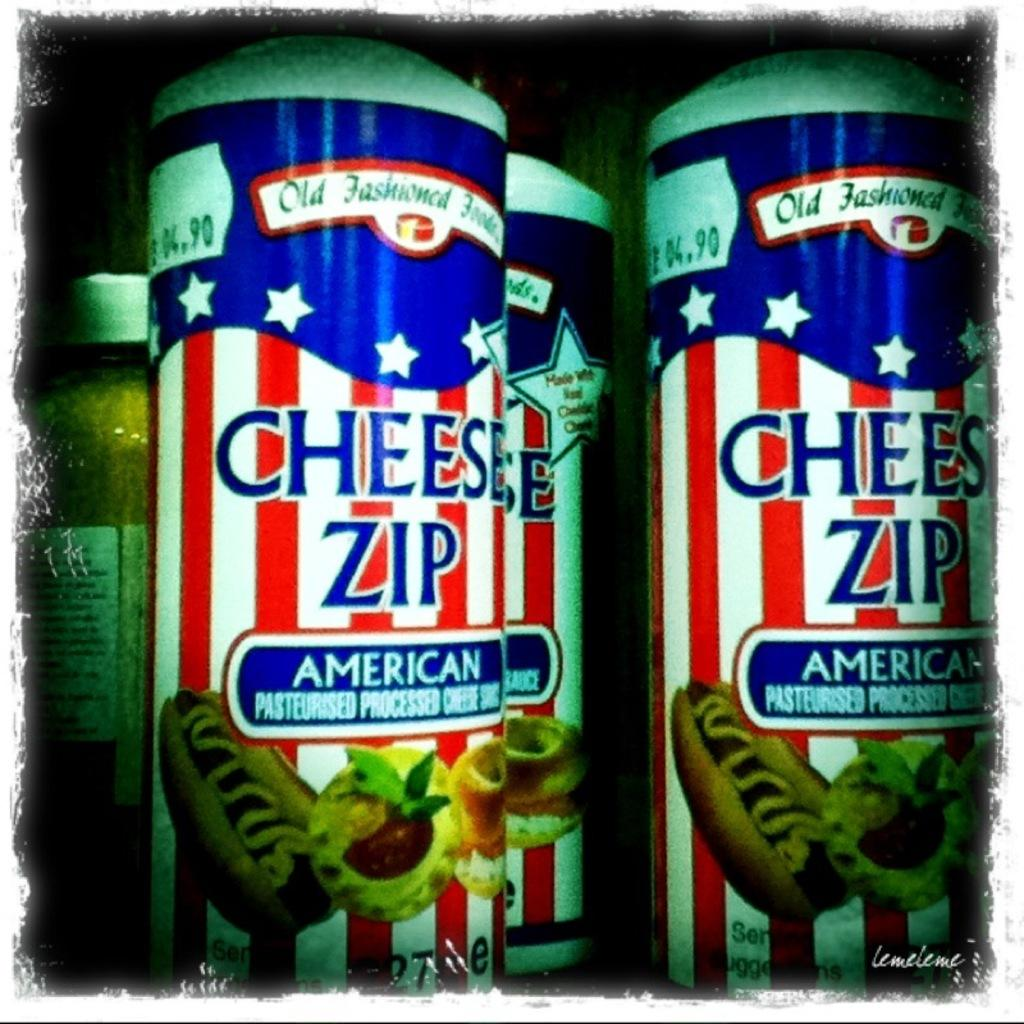Provide a one-sentence caption for the provided image. Cans containing Cheese Zip processed cheese are displayed. 